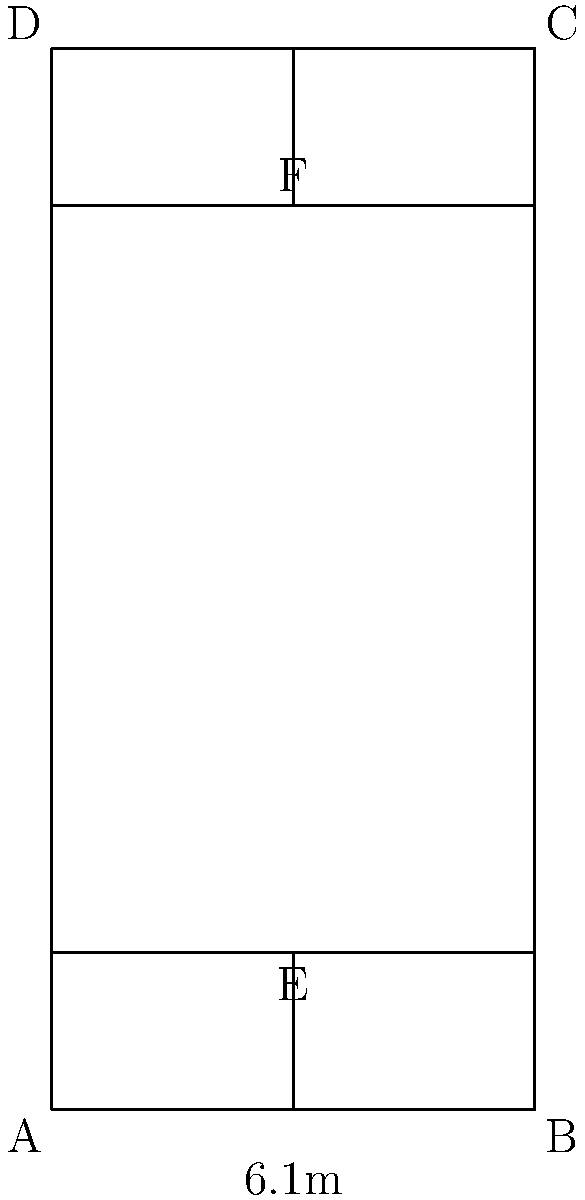In a standard badminton court, as shown in the diagram, what is the area of the service court for doubles play? Express your answer in square meters. To find the area of the service court for doubles play, we need to follow these steps:

1. Identify the service court dimensions:
   - The width of the court is 6.1 meters (AB or DC)
   - The distance from the short service line to the net is 1.98 meters (AE or BF)

2. Calculate the width of one service court:
   - The court is divided into two halves by the center line
   - Width of one service court = 6.1 m ÷ 2 = 3.05 m

3. Calculate the length of the service court:
   - Length = Distance from short service line to net = 1.98 m

4. Calculate the area of one service court:
   Area = Width × Length
   Area = 3.05 m × 1.98 m = 6.039 m²

5. The question asks for the area of the service court, which includes both sides:
   Total service court area = 6.039 m² × 2 = 12.078 m²

Therefore, the area of the service court for doubles play is 12.078 square meters.
Answer: 12.078 m² 